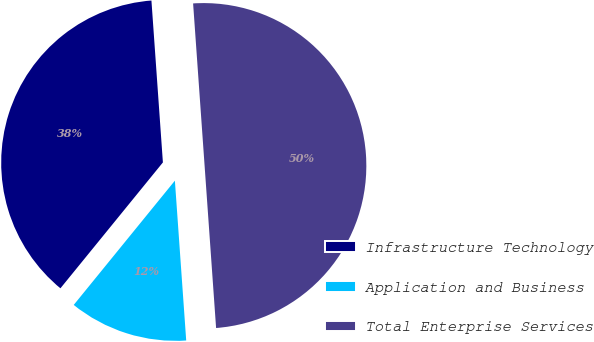Convert chart. <chart><loc_0><loc_0><loc_500><loc_500><pie_chart><fcel>Infrastructure Technology<fcel>Application and Business<fcel>Total Enterprise Services<nl><fcel>38.0%<fcel>12.0%<fcel>50.0%<nl></chart> 